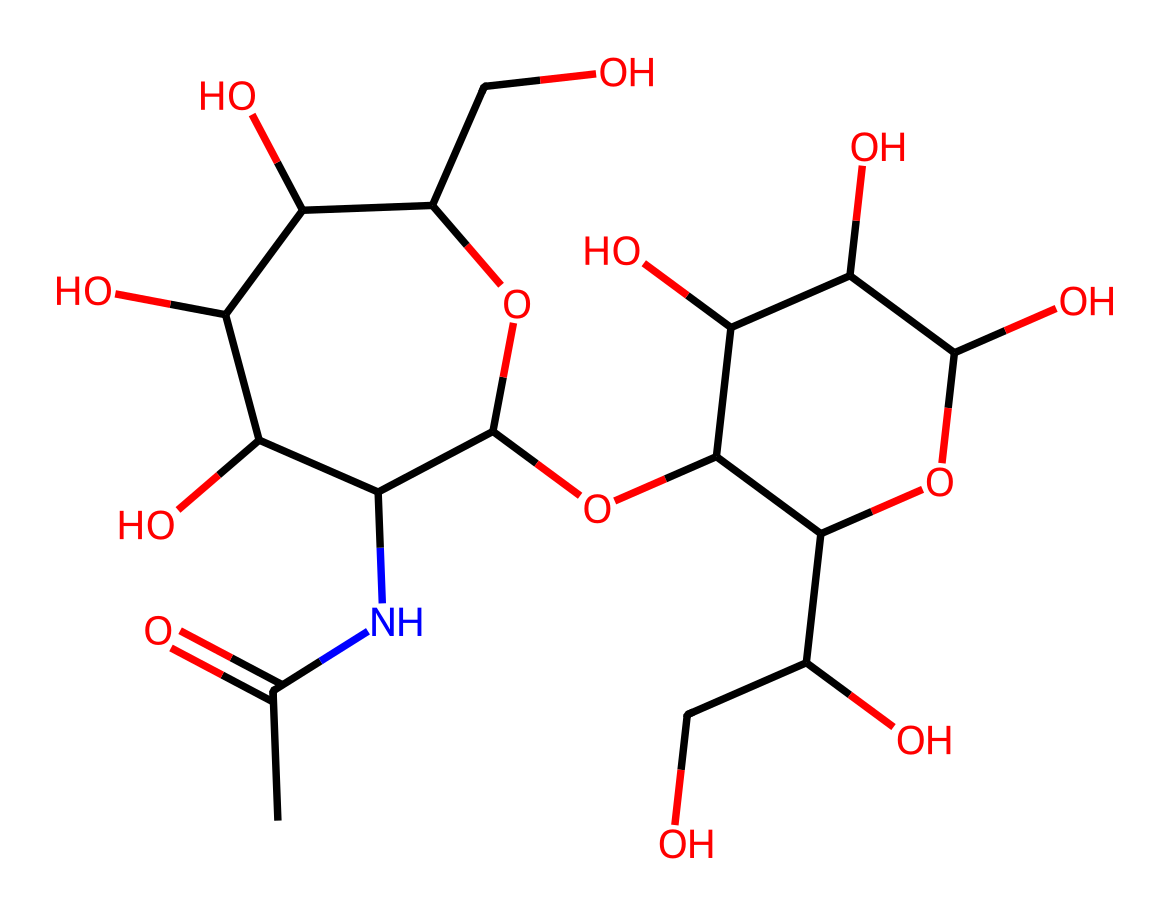How many carbon atoms are present in this structure? By analyzing the provided SMILES representation, we count the number of 'C' characters, which corresponds to the carbon atoms in the molecule. There are a total of 12 carbon atoms in this structure.
Answer: 12 What functional groups can be identified in this chemical? A careful review of the SMILES reveals the presence of hydroxyl (-OH), amine (-NH), and ether (C-O-C) functional groups. Multiple -OH groups indicate that this compound is a polyol, while the presence of the amine group suggests nitrogen functionality.
Answer: hydroxyl, amine, ether Is this chemical likely to be hydrophilic or hydrophobic? The presence of multiple hydroxyl groups increases the polarity of the molecule, making it more soluble in water. Since these attributes indicate a tendency to interact favorably with water, this chemical is hydrophilic.
Answer: hydrophilic Which part of the molecule is primarily responsible for its moisturizing properties? The extensive network of hydroxyl groups is crucial for attracting and retaining water, making this part of the molecule responsible for its moisturizing properties. Thus, the polyol nature contributes directly to its efficacy as a moisturizer.
Answer: hydroxyl groups How many cyclic structures are in the chemical? Reviewing the SMILES notation, we can identify that there are two cyclic structures denoted by 'C1' and 'C2', which indicate ring closures. This confirms the presence of two rings in this chemical structure.
Answer: 2 Does this chemical contain any nitrogen atoms? The SMILES representation includes an 'N' character, indicating at least one nitrogen atom is present in the structure, confirming that there is nitrogen in the chemical.
Answer: yes 